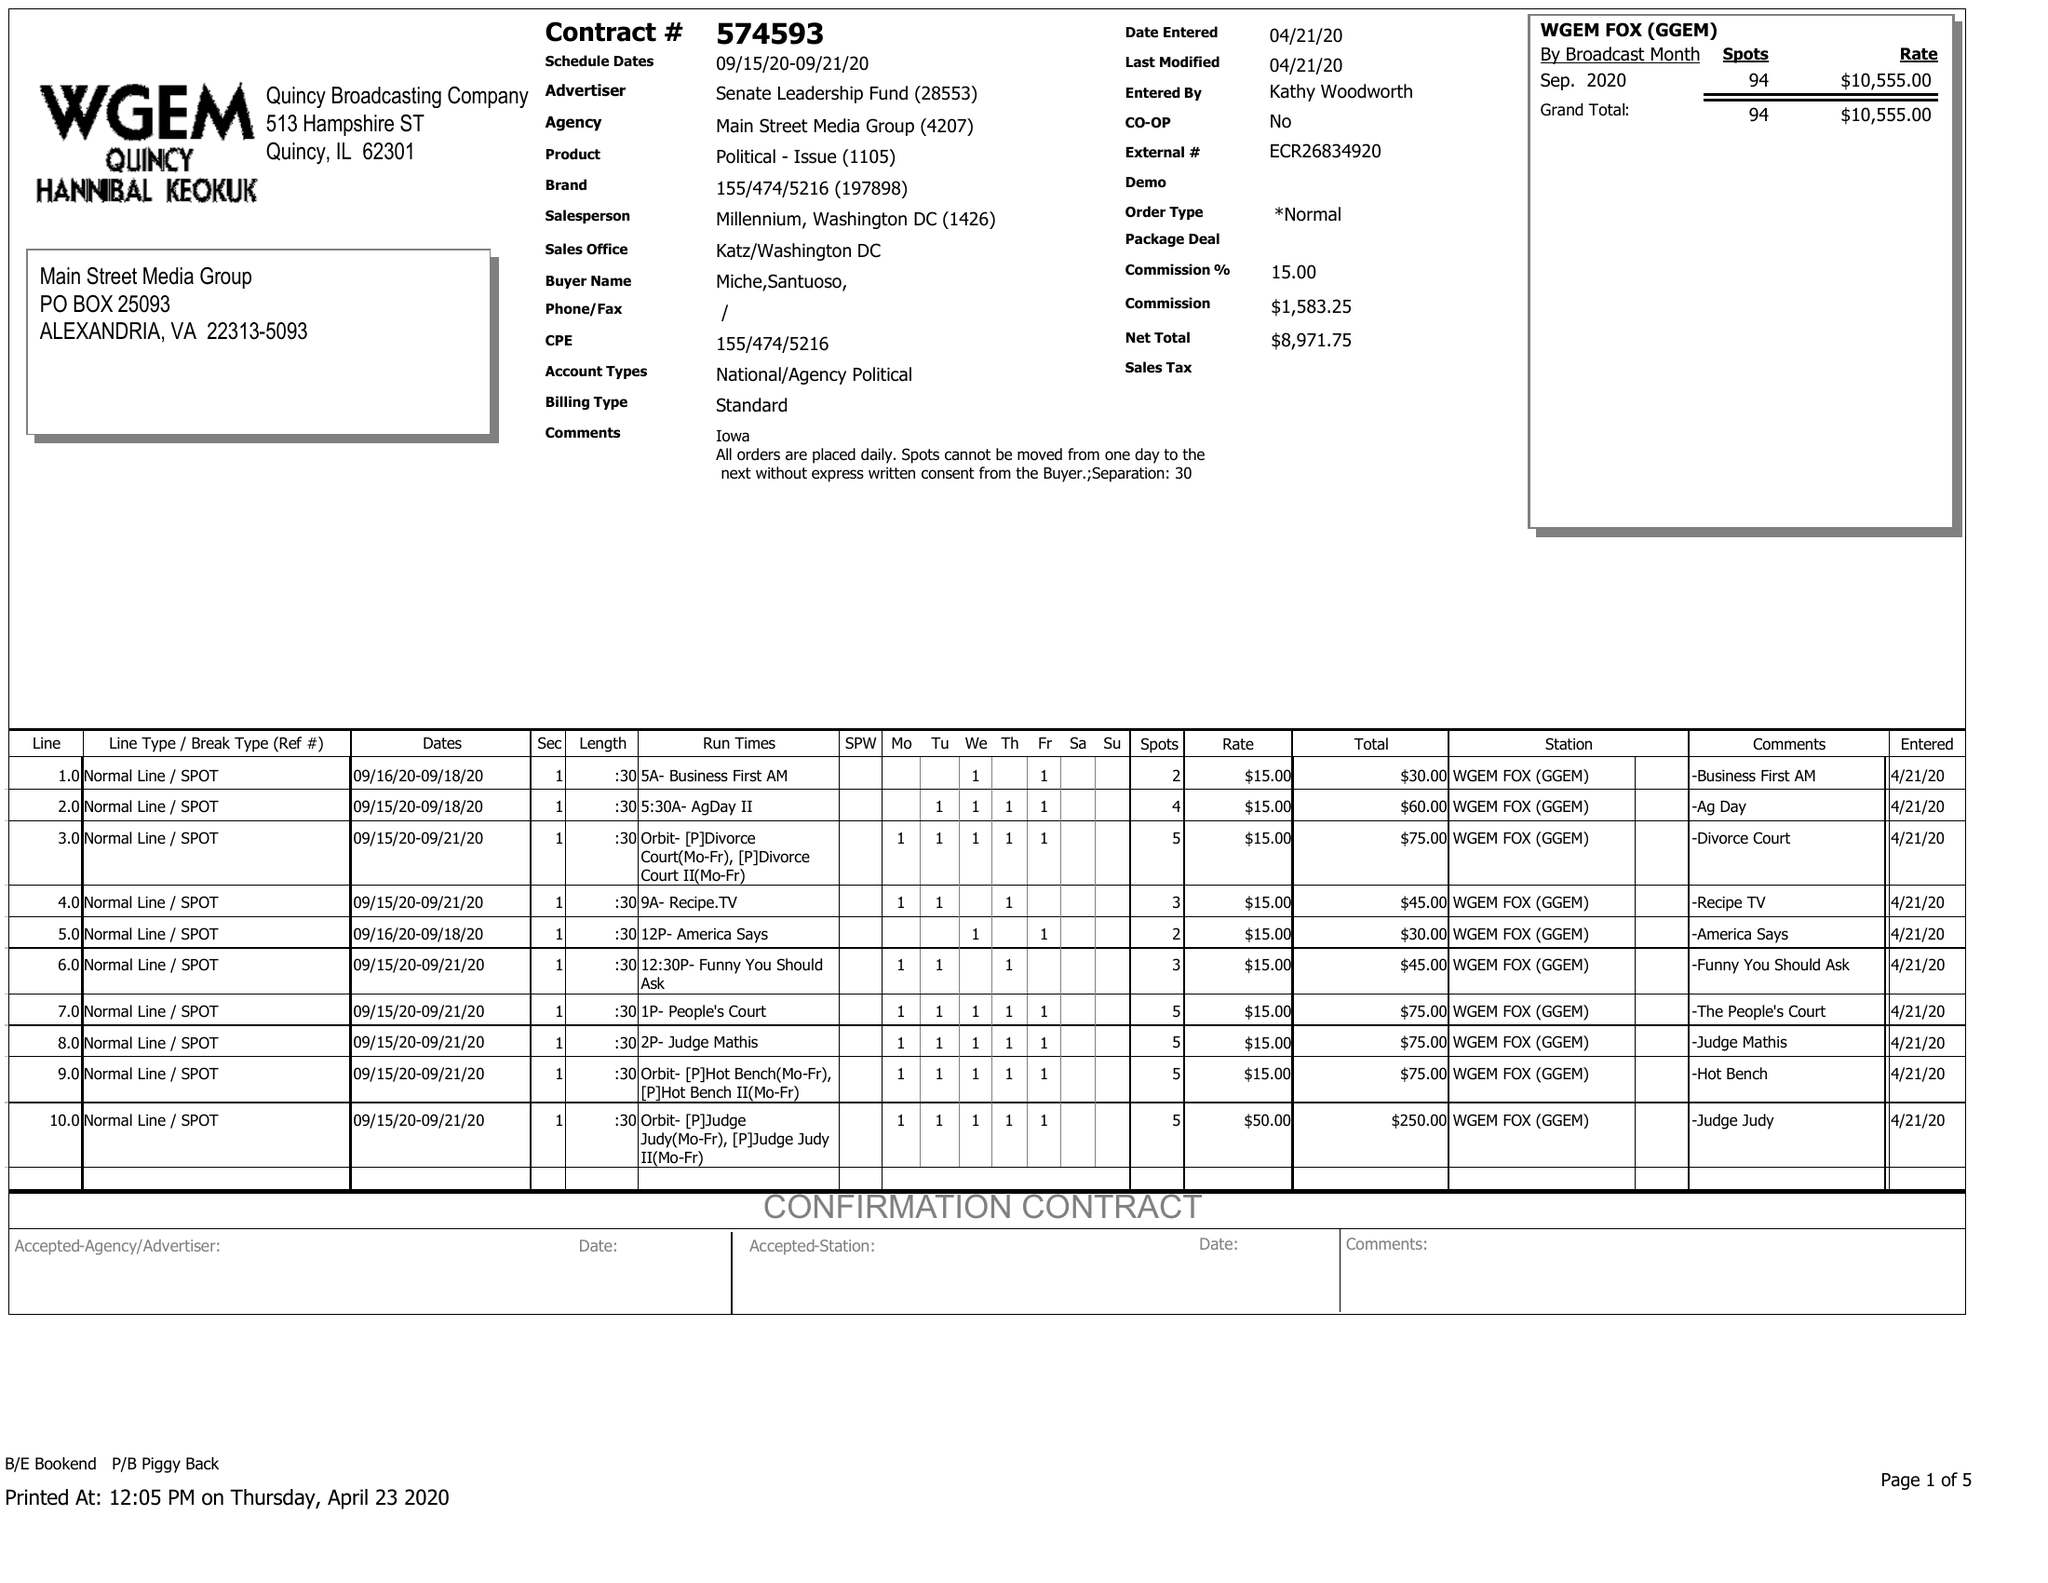What is the value for the advertiser?
Answer the question using a single word or phrase. SENATE LEADERSHIP FUND 